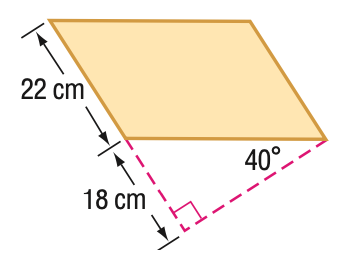Answer the mathemtical geometry problem and directly provide the correct option letter.
Question: Find the area of the parallelogram. Round to the nearest tenth if necessary.
Choices: A: 332.3 B: 396 C: 471.9 D: 616.1 C 